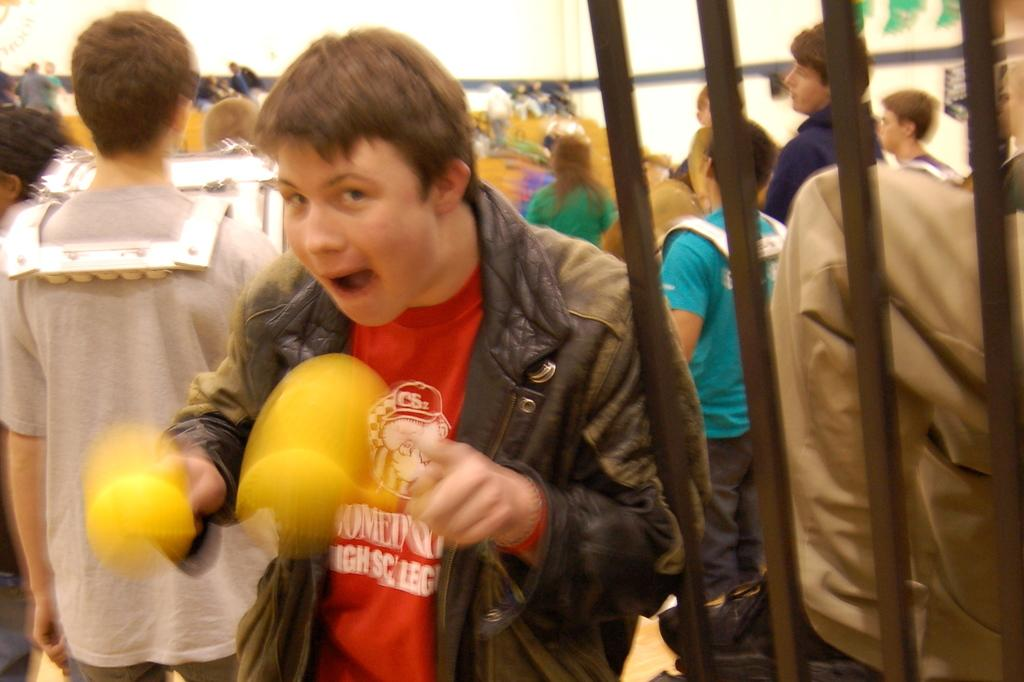How many people are present in the image? There are people in the image, but the exact number is not specified. What are some people doing in the image? Some people are holding objects in the image. What can be seen near the people in the image? There are grills in the image. Can you describe the appearance of one person in the image? There is a person wearing a costume in the image. What type of structure is visible in the image? There is a wall in the image. What type of clock can be seen hanging on the wall in the image? There is no clock visible in the image; only a wall is mentioned. What flavor of collar is the dog wearing in the image? There is no dog or collar present in the image. 